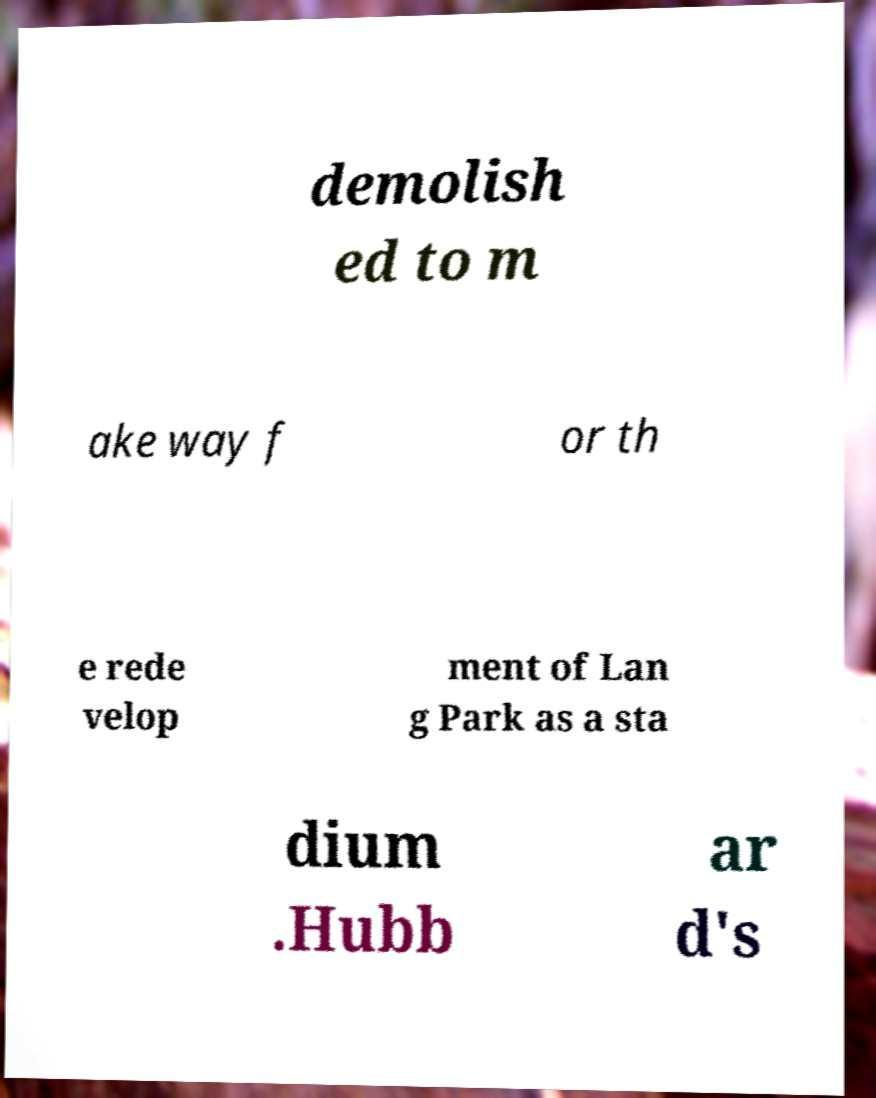Could you assist in decoding the text presented in this image and type it out clearly? demolish ed to m ake way f or th e rede velop ment of Lan g Park as a sta dium .Hubb ar d's 